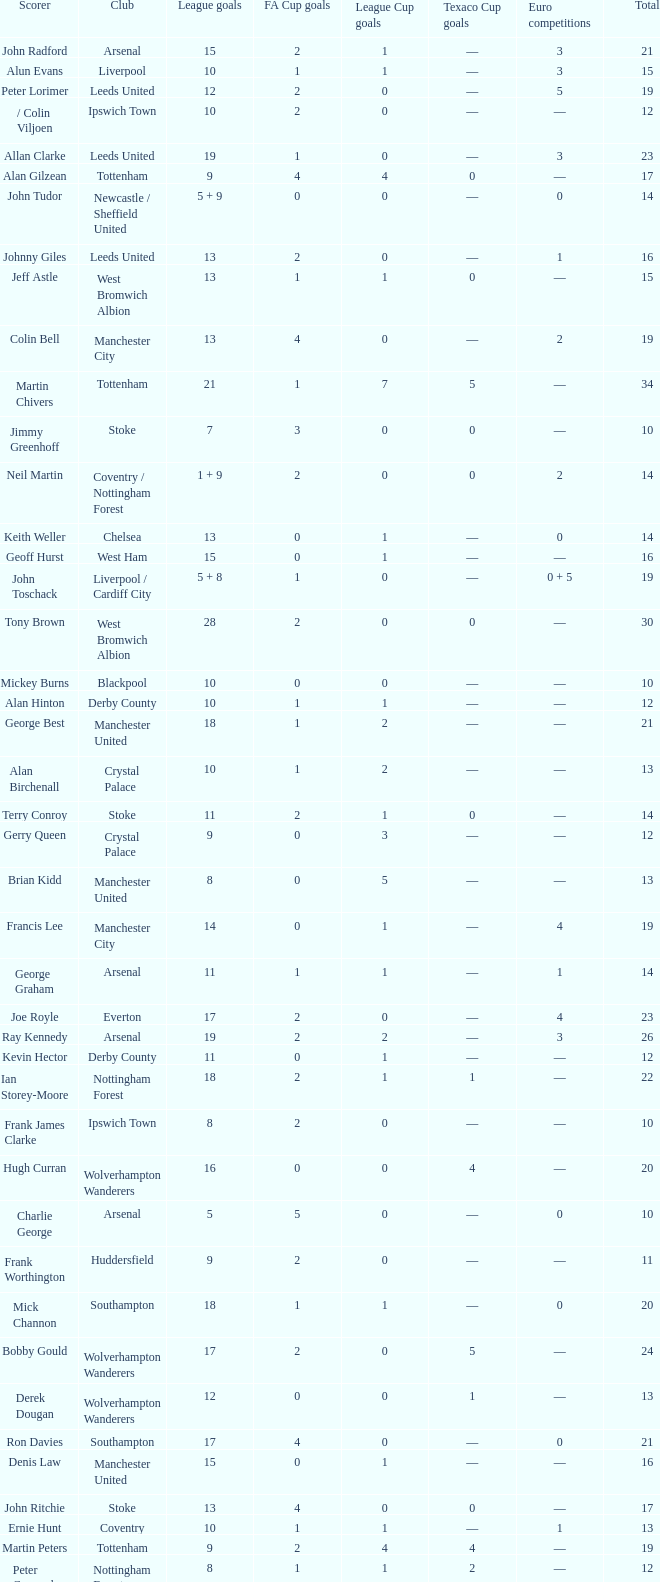What is the lowest League Cup Goals, when Scorer is Denis Law? 1.0. 